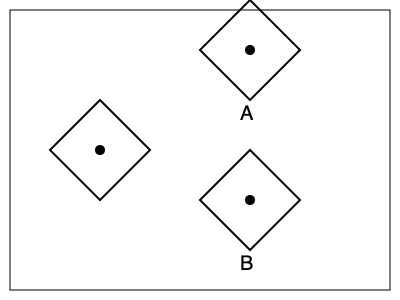In a prison workshop designed to improve inmates' spatial reasoning skills, you present the following problem: Which of the shapes (A or B) can be rotated to match the target shape on the left? Consider this exercise as part of the rehabilitation program aimed at enhancing cognitive abilities. To solve this problem, we need to mentally rotate the given shapes and compare them to the target shape. Let's analyze each step:

1. Observe the target shape:
   - It's a diamond-like quadrilateral with a circle at its center.
   - The top vertex is slightly higher than the bottom vertex.

2. Analyze Shape A:
   - It's also a diamond-like quadrilateral with a circle at its center.
   - The orientation is different, with the right vertex being the highest point.
   - If we rotate this shape 90 degrees counterclockwise, it will match the target shape.

3. Analyze Shape B:
   - It's a diamond-like quadrilateral with a circle at its center.
   - The orientation is similar to the target shape, but it's upside down.
   - No single rotation can make this shape match the target shape.

4. Conclusion:
   Shape A can be rotated to match the target shape, while Shape B cannot.

This exercise demonstrates the importance of mental rotation skills, which can be beneficial for inmates in various practical applications and problem-solving scenarios during their rehabilitation process.
Answer: A 